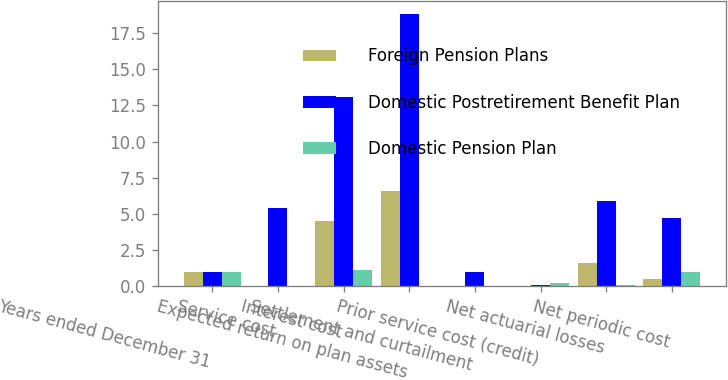<chart> <loc_0><loc_0><loc_500><loc_500><stacked_bar_chart><ecel><fcel>Years ended December 31<fcel>Service cost<fcel>Interest cost<fcel>Expected return on plan assets<fcel>Settlement and curtailment<fcel>Prior service cost (credit)<fcel>Net actuarial losses<fcel>Net periodic cost<nl><fcel>Foreign Pension Plans<fcel>1<fcel>0<fcel>4.5<fcel>6.6<fcel>0<fcel>0<fcel>1.6<fcel>0.5<nl><fcel>Domestic Postretirement Benefit Plan<fcel>1<fcel>5.4<fcel>13.1<fcel>18.8<fcel>1<fcel>0.1<fcel>5.9<fcel>4.7<nl><fcel>Domestic Pension Plan<fcel>1<fcel>0<fcel>1.1<fcel>0<fcel>0<fcel>0.2<fcel>0.1<fcel>1<nl></chart> 